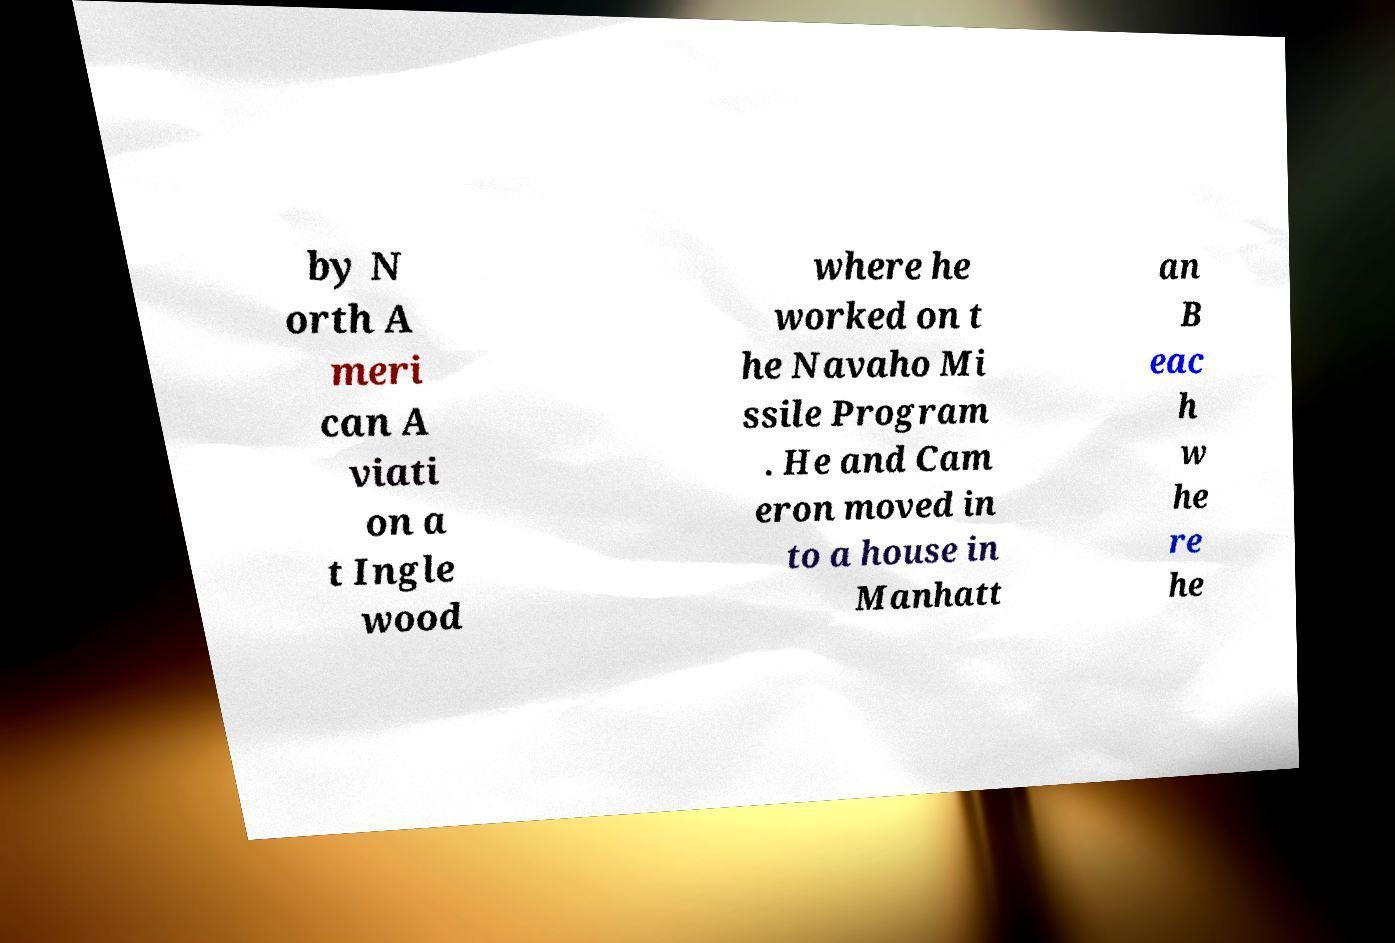There's text embedded in this image that I need extracted. Can you transcribe it verbatim? by N orth A meri can A viati on a t Ingle wood where he worked on t he Navaho Mi ssile Program . He and Cam eron moved in to a house in Manhatt an B eac h w he re he 